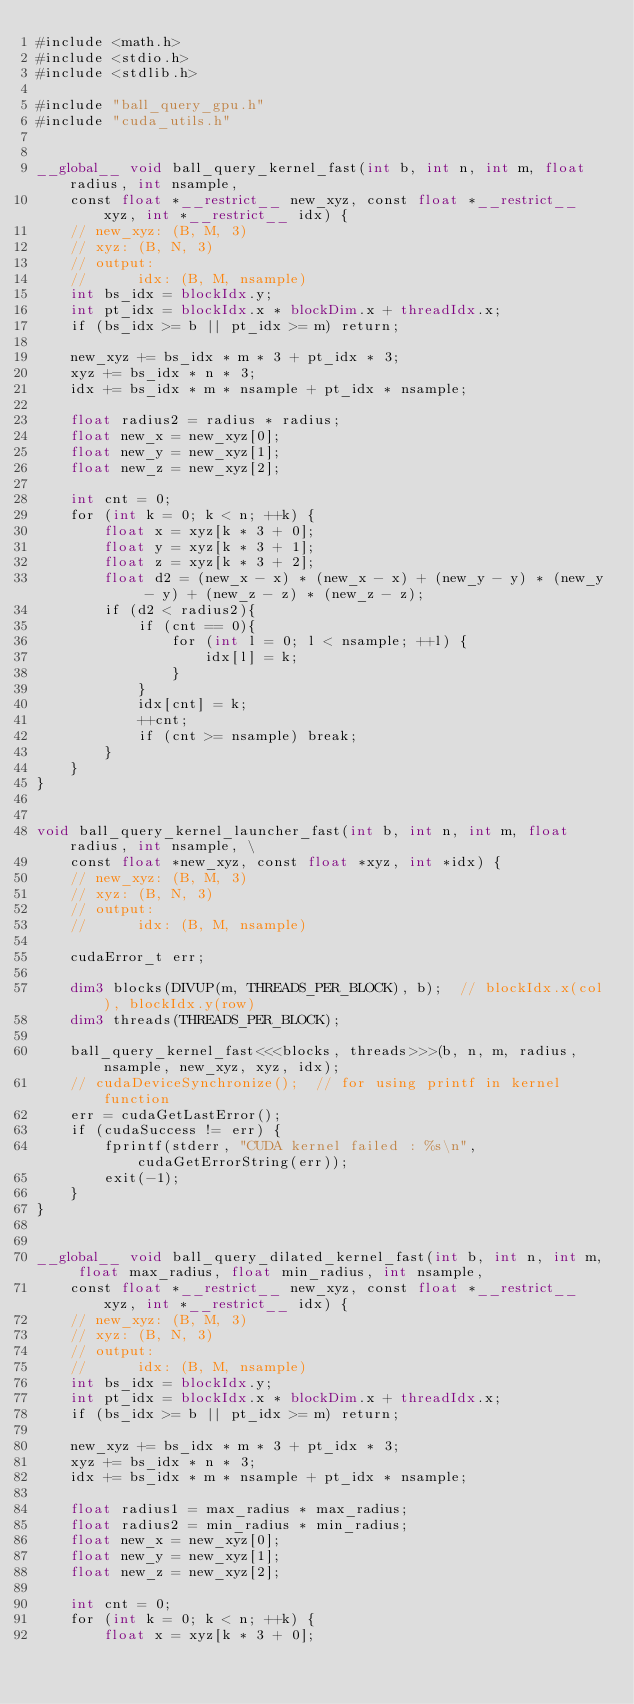<code> <loc_0><loc_0><loc_500><loc_500><_Cuda_>#include <math.h>
#include <stdio.h>
#include <stdlib.h>

#include "ball_query_gpu.h"
#include "cuda_utils.h"


__global__ void ball_query_kernel_fast(int b, int n, int m, float radius, int nsample, 
    const float *__restrict__ new_xyz, const float *__restrict__ xyz, int *__restrict__ idx) {
    // new_xyz: (B, M, 3)
    // xyz: (B, N, 3)
    // output:
    //      idx: (B, M, nsample)
    int bs_idx = blockIdx.y;
    int pt_idx = blockIdx.x * blockDim.x + threadIdx.x;
    if (bs_idx >= b || pt_idx >= m) return;

    new_xyz += bs_idx * m * 3 + pt_idx * 3;
    xyz += bs_idx * n * 3;
    idx += bs_idx * m * nsample + pt_idx * nsample;

    float radius2 = radius * radius;
    float new_x = new_xyz[0];
    float new_y = new_xyz[1];
    float new_z = new_xyz[2];

    int cnt = 0;
    for (int k = 0; k < n; ++k) {
        float x = xyz[k * 3 + 0];
        float y = xyz[k * 3 + 1];
        float z = xyz[k * 3 + 2];
        float d2 = (new_x - x) * (new_x - x) + (new_y - y) * (new_y - y) + (new_z - z) * (new_z - z);
        if (d2 < radius2){
            if (cnt == 0){
                for (int l = 0; l < nsample; ++l) {
                    idx[l] = k;
                }
            }
            idx[cnt] = k;
            ++cnt;
            if (cnt >= nsample) break;
        }
    }
}


void ball_query_kernel_launcher_fast(int b, int n, int m, float radius, int nsample, \
    const float *new_xyz, const float *xyz, int *idx) {
    // new_xyz: (B, M, 3)
    // xyz: (B, N, 3)
    // output:
    //      idx: (B, M, nsample)

    cudaError_t err;

    dim3 blocks(DIVUP(m, THREADS_PER_BLOCK), b);  // blockIdx.x(col), blockIdx.y(row)
    dim3 threads(THREADS_PER_BLOCK);

    ball_query_kernel_fast<<<blocks, threads>>>(b, n, m, radius, nsample, new_xyz, xyz, idx);
    // cudaDeviceSynchronize();  // for using printf in kernel function
    err = cudaGetLastError();
    if (cudaSuccess != err) {
        fprintf(stderr, "CUDA kernel failed : %s\n", cudaGetErrorString(err));
        exit(-1);
    }
}


__global__ void ball_query_dilated_kernel_fast(int b, int n, int m, float max_radius, float min_radius, int nsample, 
    const float *__restrict__ new_xyz, const float *__restrict__ xyz, int *__restrict__ idx) {
    // new_xyz: (B, M, 3)
    // xyz: (B, N, 3)
    // output:
    //      idx: (B, M, nsample)
    int bs_idx = blockIdx.y;
    int pt_idx = blockIdx.x * blockDim.x + threadIdx.x;
    if (bs_idx >= b || pt_idx >= m) return;

    new_xyz += bs_idx * m * 3 + pt_idx * 3;
    xyz += bs_idx * n * 3;
    idx += bs_idx * m * nsample + pt_idx * nsample;

    float radius1 = max_radius * max_radius;
    float radius2 = min_radius * min_radius;
    float new_x = new_xyz[0];
    float new_y = new_xyz[1];
    float new_z = new_xyz[2];

    int cnt = 0;
    for (int k = 0; k < n; ++k) {
        float x = xyz[k * 3 + 0];</code> 